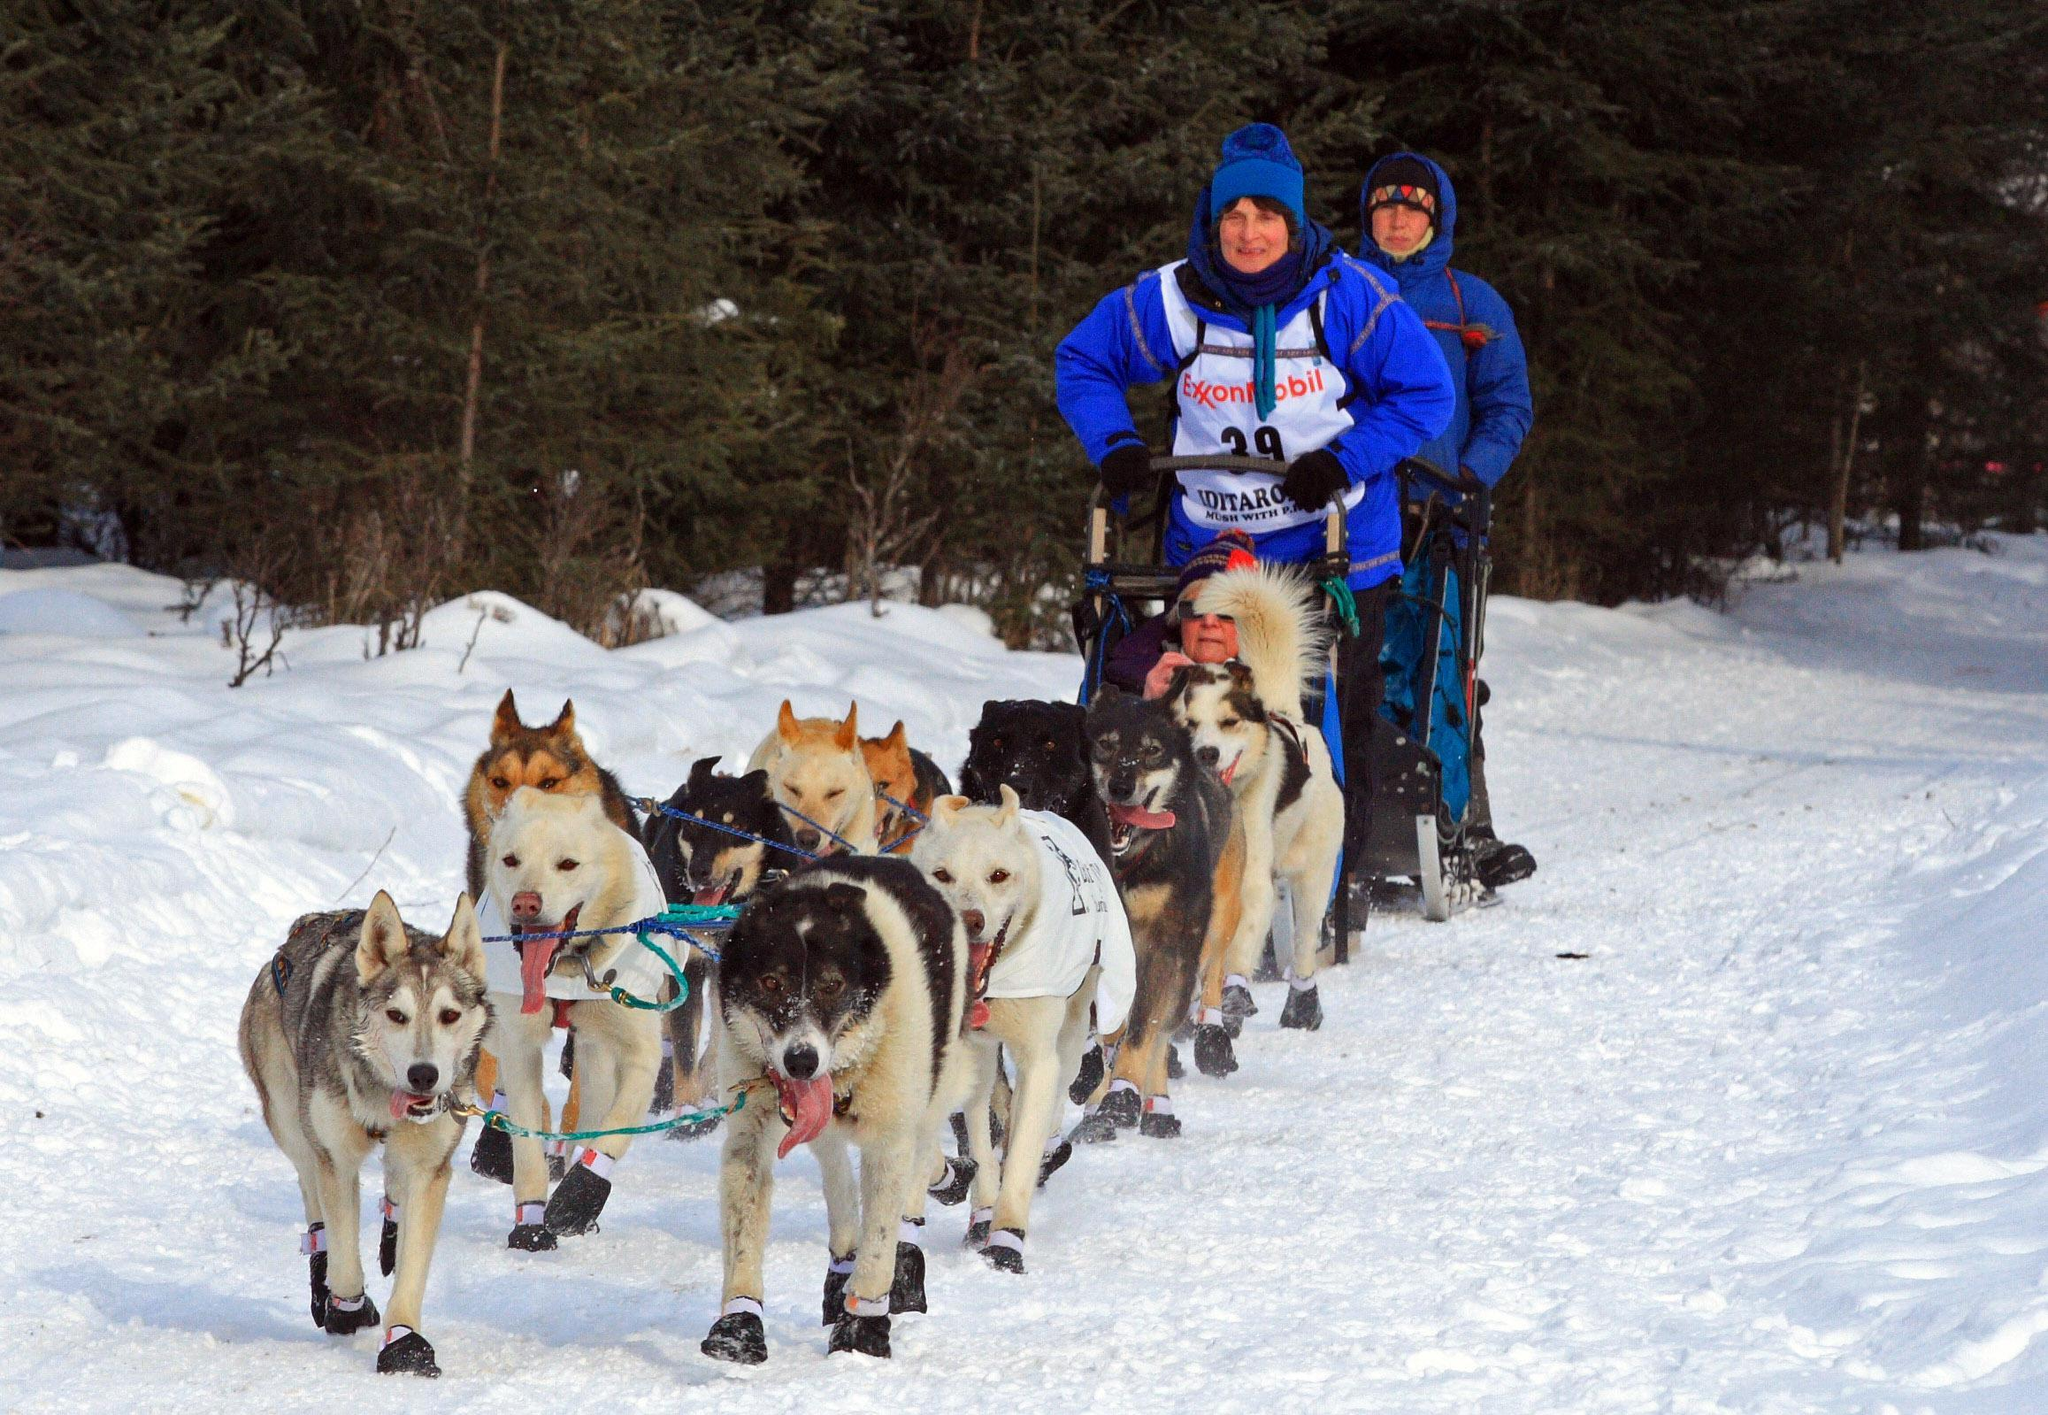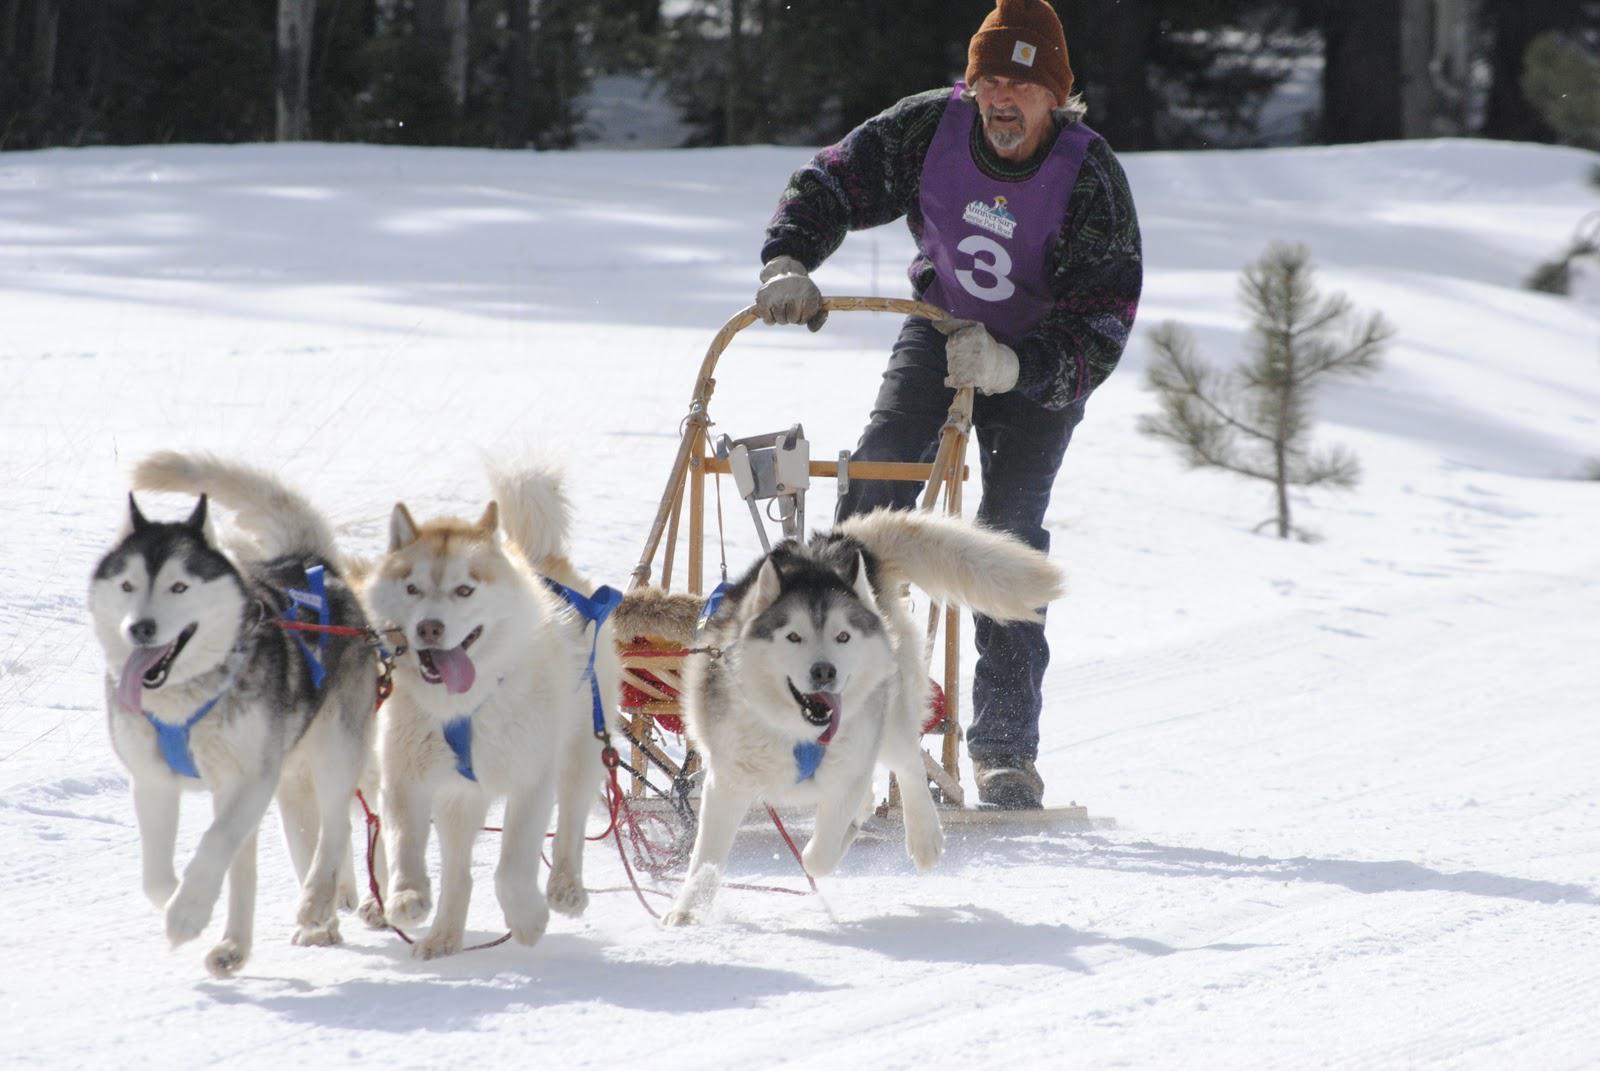The first image is the image on the left, the second image is the image on the right. Given the left and right images, does the statement "There are 3 sled dogs pulling a sled" hold true? Answer yes or no. Yes. The first image is the image on the left, the second image is the image on the right. For the images displayed, is the sentence "In one image, three dogs pulling a sled are visible." factually correct? Answer yes or no. Yes. 